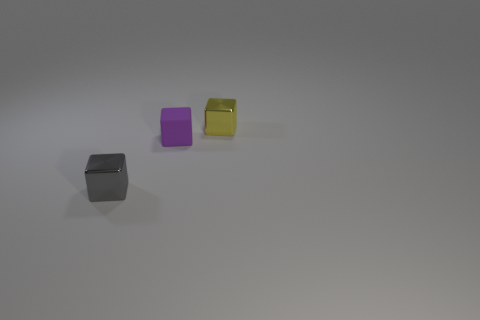Are there any other tiny things made of the same material as the gray thing?
Provide a short and direct response. Yes. What number of objects are either green metallic balls or small gray metal things?
Your response must be concise. 1. Is the material of the yellow thing the same as the block on the left side of the purple block?
Ensure brevity in your answer.  Yes. What is the size of the shiny cube that is in front of the tiny purple rubber block?
Provide a short and direct response. Small. Is the number of red rubber cylinders less than the number of purple things?
Provide a short and direct response. Yes. Is there another small block of the same color as the tiny rubber block?
Your response must be concise. No. There is a thing that is both in front of the small yellow object and right of the gray object; what shape is it?
Make the answer very short. Cube. What shape is the tiny metallic thing that is left of the shiny block right of the small gray block?
Provide a succinct answer. Cube. Is the shape of the tiny matte object the same as the small yellow shiny object?
Offer a very short reply. Yes. What number of tiny yellow shiny things are to the right of the metal cube on the right side of the small shiny thing left of the tiny rubber thing?
Offer a terse response. 0. 